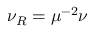<formula> <loc_0><loc_0><loc_500><loc_500>\begin{array} { r } { \nu _ { R } = \mu ^ { - 2 } \nu } \end{array}</formula> 